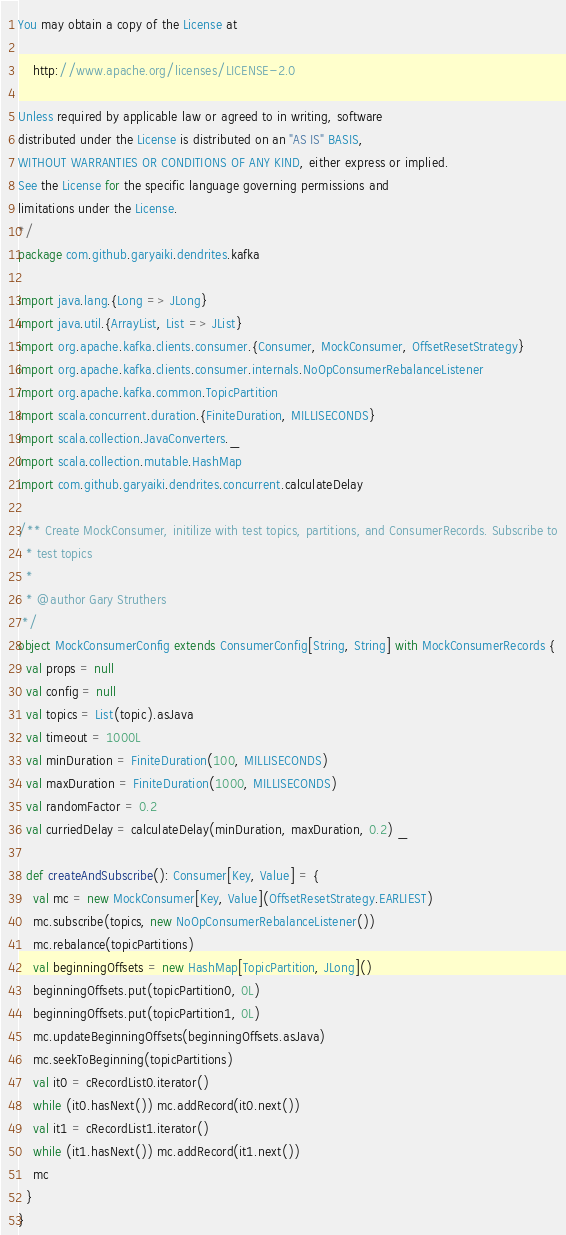Convert code to text. <code><loc_0><loc_0><loc_500><loc_500><_Scala_>You may obtain a copy of the License at

    http://www.apache.org/licenses/LICENSE-2.0

Unless required by applicable law or agreed to in writing, software
distributed under the License is distributed on an "AS IS" BASIS,
WITHOUT WARRANTIES OR CONDITIONS OF ANY KIND, either express or implied.
See the License for the specific language governing permissions and
limitations under the License.
*/
package com.github.garyaiki.dendrites.kafka

import java.lang.{Long => JLong}
import java.util.{ArrayList, List => JList}
import org.apache.kafka.clients.consumer.{Consumer, MockConsumer, OffsetResetStrategy}
import org.apache.kafka.clients.consumer.internals.NoOpConsumerRebalanceListener
import org.apache.kafka.common.TopicPartition
import scala.concurrent.duration.{FiniteDuration, MILLISECONDS}
import scala.collection.JavaConverters._
import scala.collection.mutable.HashMap
import com.github.garyaiki.dendrites.concurrent.calculateDelay

/** Create MockConsumer, initilize with test topics, partitions, and ConsumerRecords. Subscribe to
  * test topics
  *
  * @author Gary Struthers
 */
object MockConsumerConfig extends ConsumerConfig[String, String] with MockConsumerRecords {
  val props = null
  val config = null
  val topics = List(topic).asJava
  val timeout = 1000L
  val minDuration = FiniteDuration(100, MILLISECONDS)
  val maxDuration = FiniteDuration(1000, MILLISECONDS)
  val randomFactor = 0.2
  val curriedDelay = calculateDelay(minDuration, maxDuration, 0.2) _

  def createAndSubscribe(): Consumer[Key, Value] = {
    val mc = new MockConsumer[Key, Value](OffsetResetStrategy.EARLIEST)
    mc.subscribe(topics, new NoOpConsumerRebalanceListener())
    mc.rebalance(topicPartitions)
    val beginningOffsets = new HashMap[TopicPartition, JLong]()
    beginningOffsets.put(topicPartition0, 0L)
    beginningOffsets.put(topicPartition1, 0L)
    mc.updateBeginningOffsets(beginningOffsets.asJava)
    mc.seekToBeginning(topicPartitions)
    val it0 = cRecordList0.iterator()
    while (it0.hasNext()) mc.addRecord(it0.next())
    val it1 = cRecordList1.iterator()
    while (it1.hasNext()) mc.addRecord(it1.next())
    mc
  }
}
</code> 